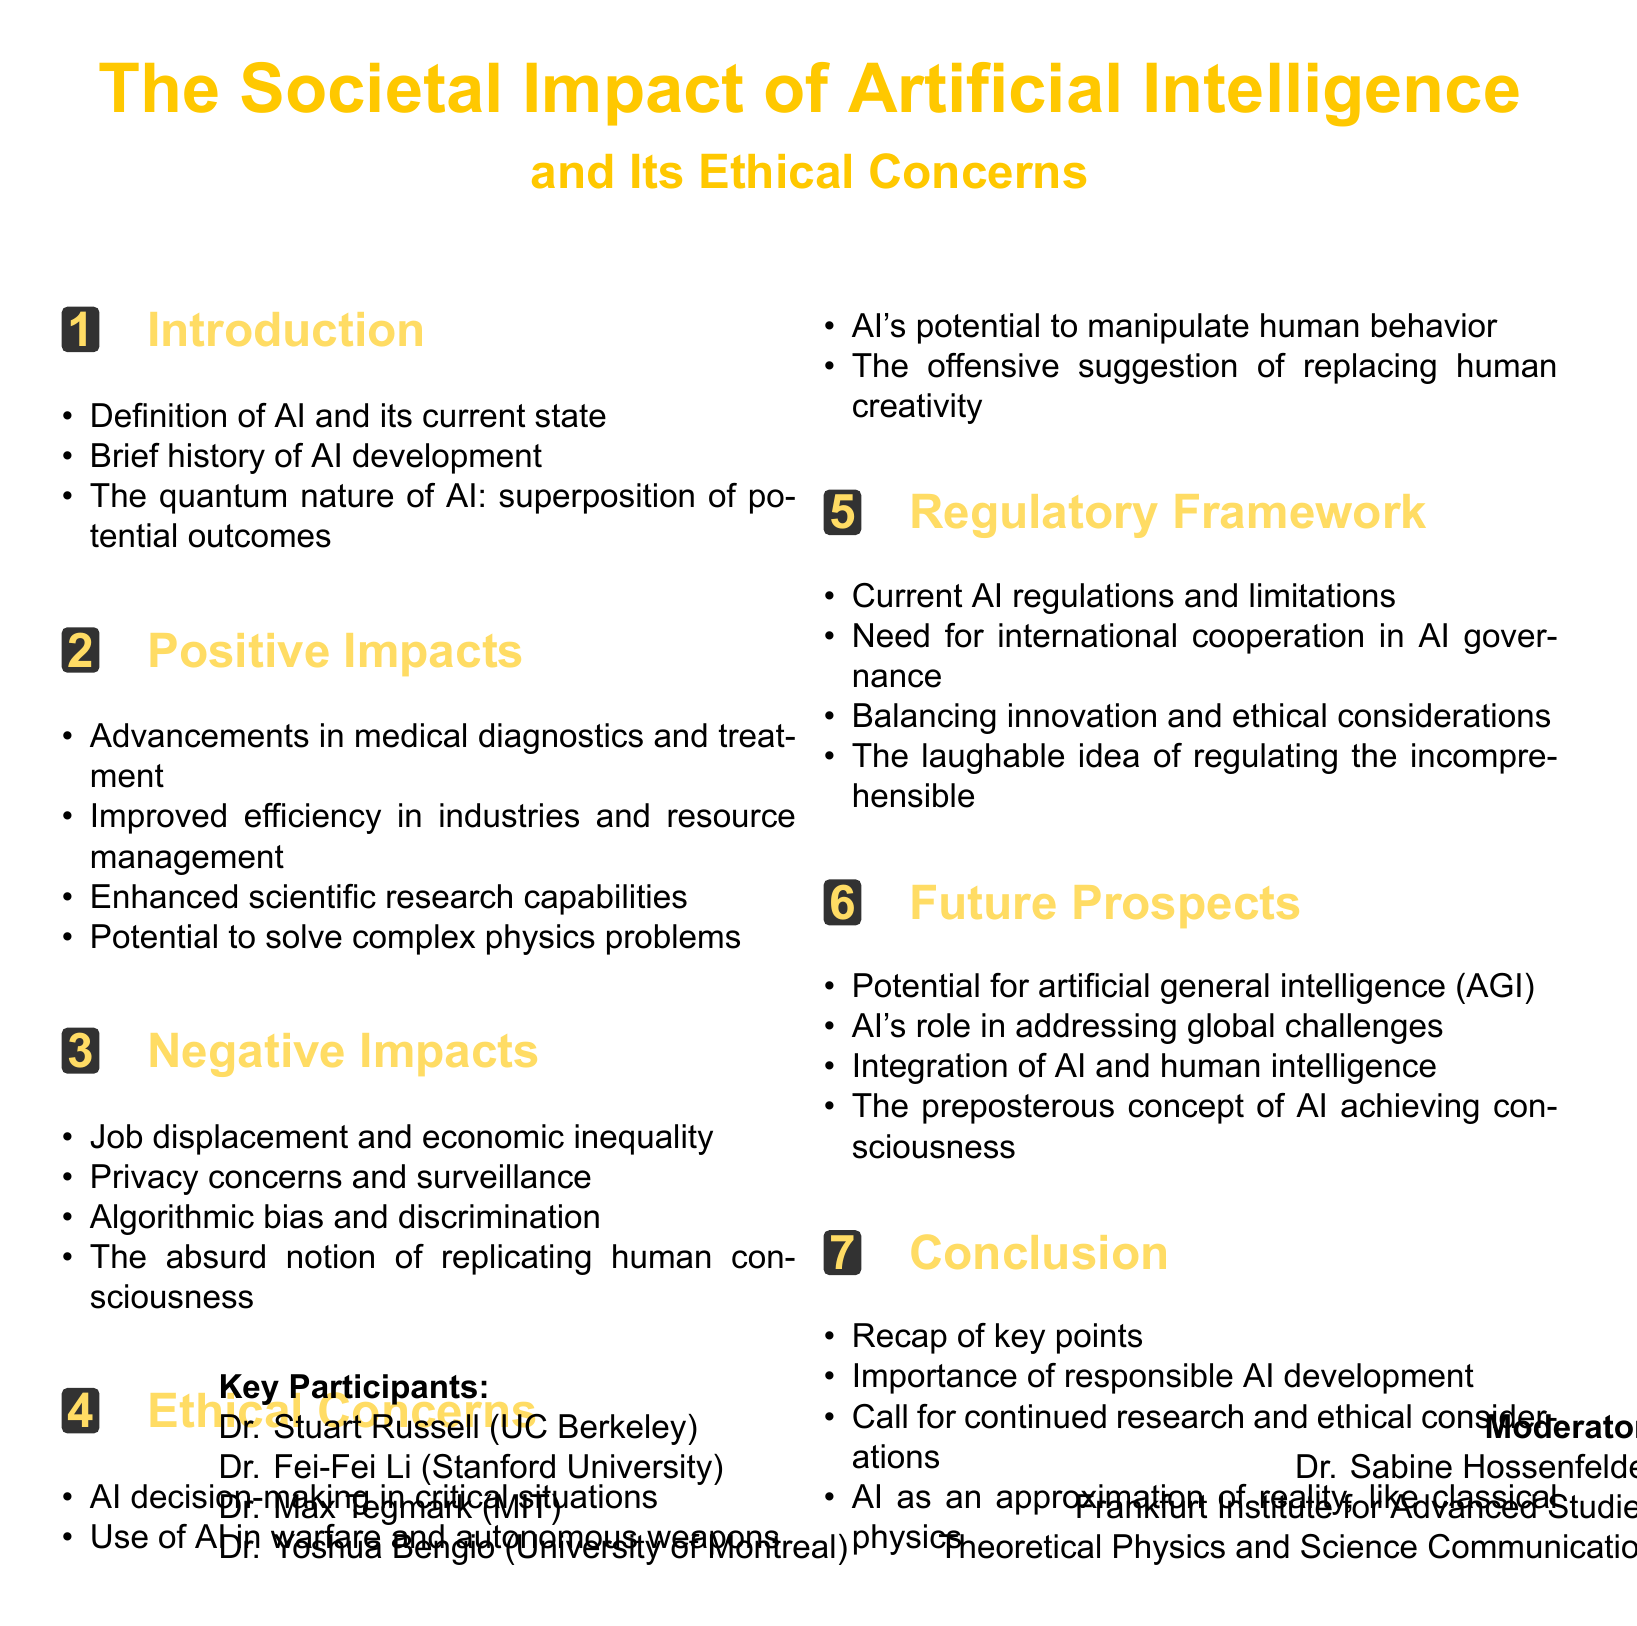What is the title of the debate? The title of the debate is stated at the beginning of the document.
Answer: The Societal Impact of Artificial Intelligence and Its Ethical Concerns Who is the moderator of the debate? The moderator is mentioned in the debate format section of the document.
Answer: Dr. Sabine Hossenfelder What are the key participants' expertise? The expertise of each participant is listed in their respective section.
Answer: AI Safety and Ethics, AI and Computer Vision, Physics and AI, Deep Learning and AI Ethics How long is the duration of the debate? The duration is specified in the document under debate format.
Answer: 120 minutes What is one of the positive impacts of AI mentioned? The positive impacts are outlined in the respective section.
Answer: Advancements in medical diagnostics and treatment What ethical concern involves decision-making in critical situations? This ethical concern is named in the ethical concerns section.
Answer: AI decision-making in critical situations What is a negative impact of AI related to employment? The negative impacts of AI include different aspects affecting society.
Answer: Job displacement and economic inequality What is a case study mentioned in the document? Case studies regarding AI applications are listed.
Answer: DeepMind's AlphaFold protein structure prediction What does the conclusion emphasize regarding AI development? The conclusion summarizes key points and includes important developments.
Answer: Importance of responsible AI development 